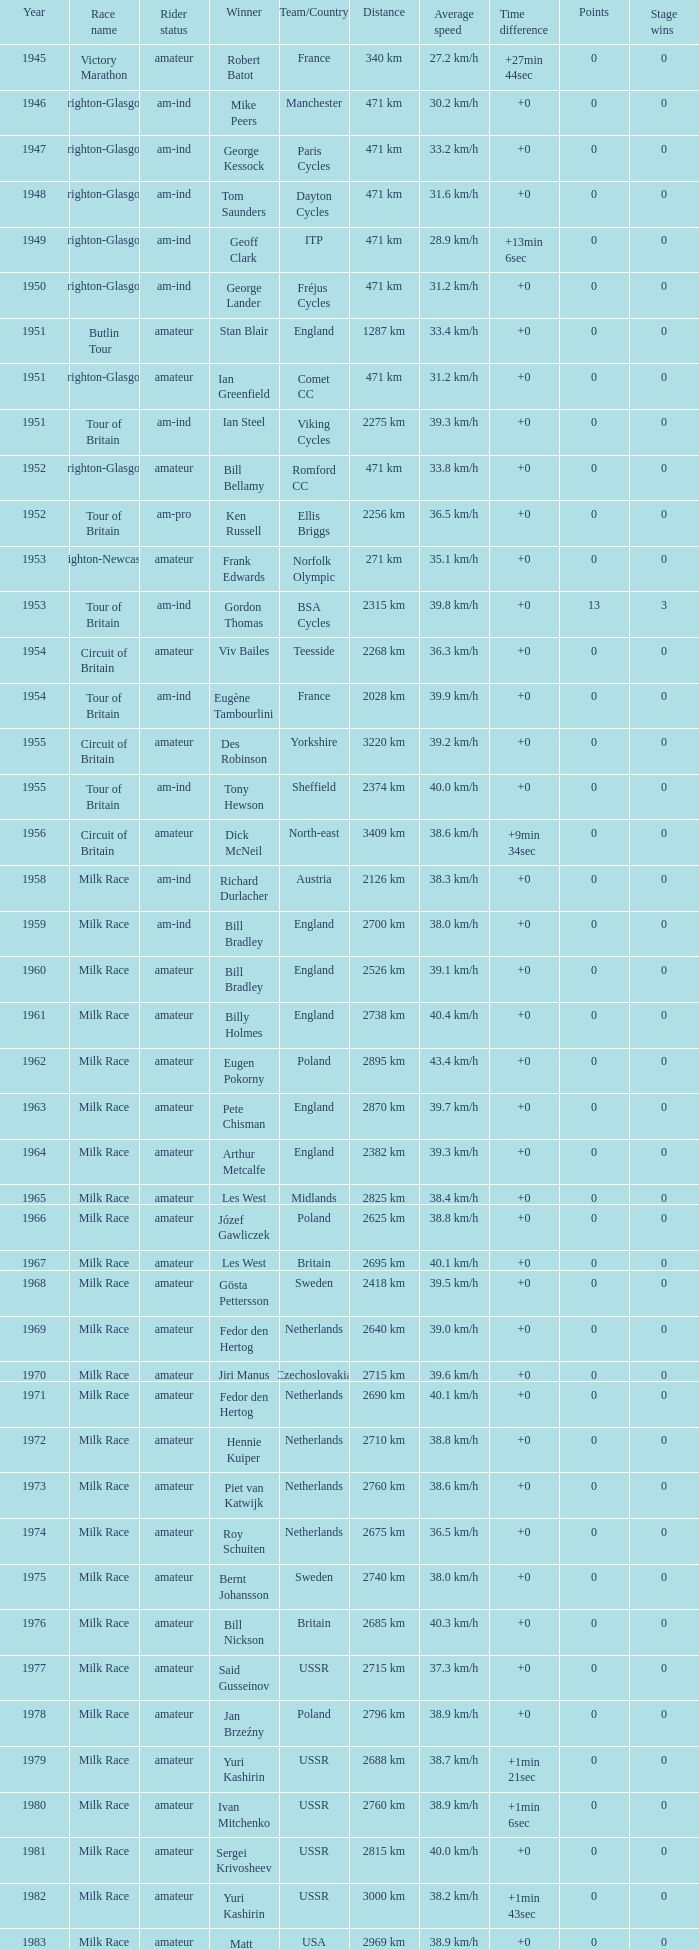Who was the winner in 1973 with an amateur rider status? Piet van Katwijk. 